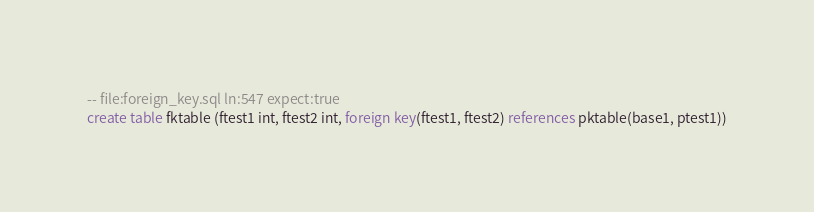<code> <loc_0><loc_0><loc_500><loc_500><_SQL_>-- file:foreign_key.sql ln:547 expect:true
create table fktable (ftest1 int, ftest2 int, foreign key(ftest1, ftest2) references pktable(base1, ptest1))
</code> 